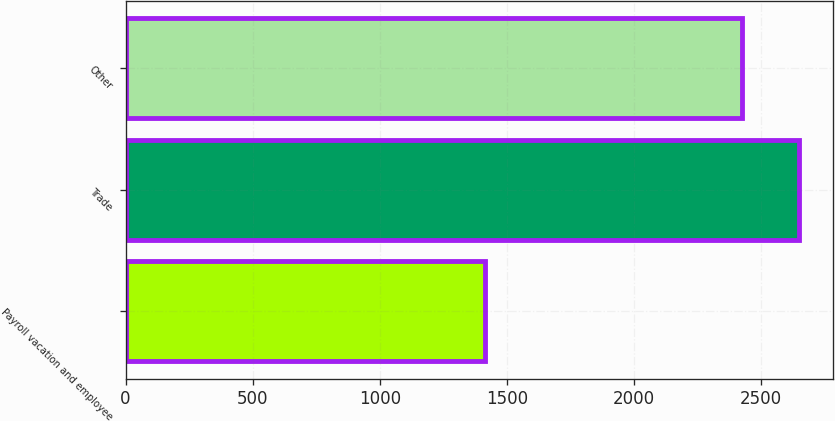Convert chart to OTSL. <chart><loc_0><loc_0><loc_500><loc_500><bar_chart><fcel>Payroll vacation and employee<fcel>Trade<fcel>Other<nl><fcel>1414<fcel>2649<fcel>2425<nl></chart> 